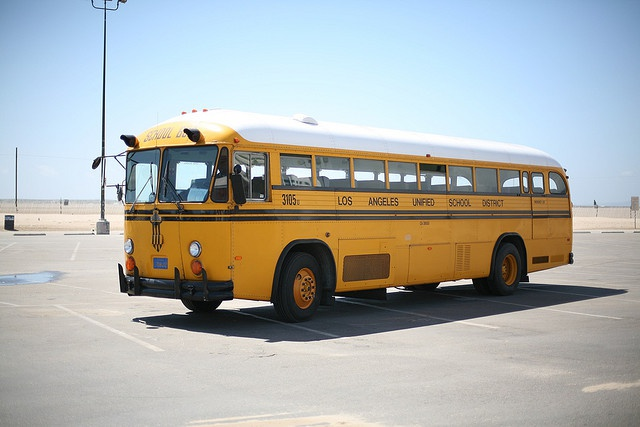Describe the objects in this image and their specific colors. I can see bus in gray, olive, black, white, and orange tones and people in gray and black tones in this image. 